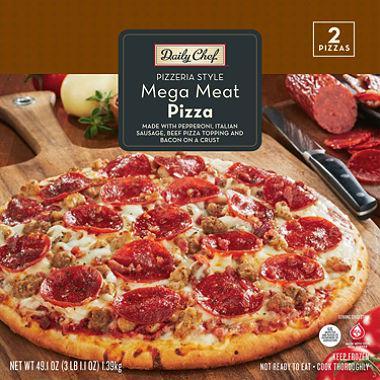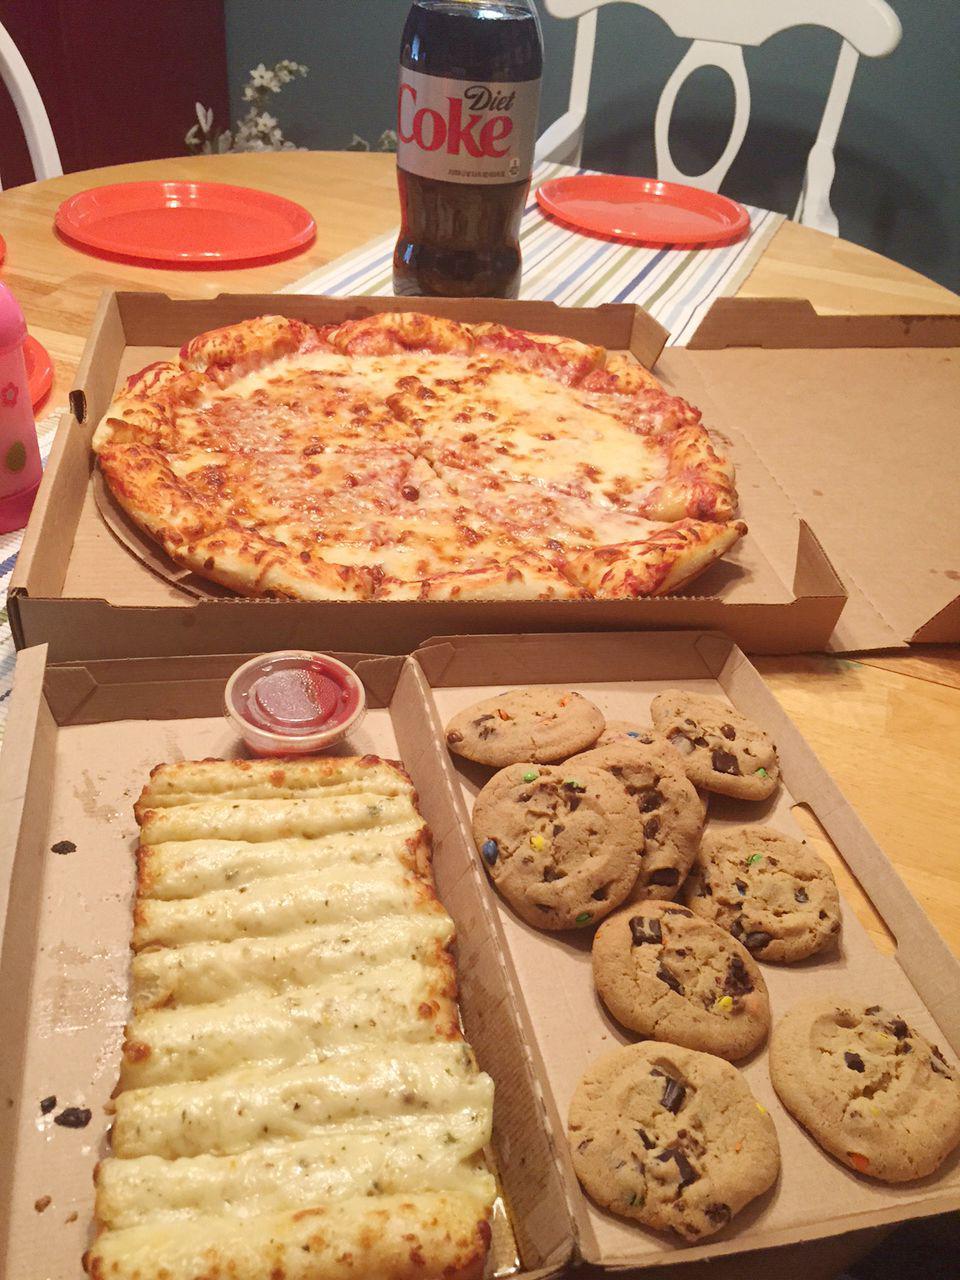The first image is the image on the left, the second image is the image on the right. Assess this claim about the two images: "The left image includes a pizza in an open box, a plate containing a row of cheesy bread with a container of red sauce next to it, a plate of cookies, and a bottle of cola beside the pizza box.". Correct or not? Answer yes or no. No. The first image is the image on the left, the second image is the image on the right. Examine the images to the left and right. Is the description "The pizza in the image on the right is lying in a cardboard box." accurate? Answer yes or no. Yes. 